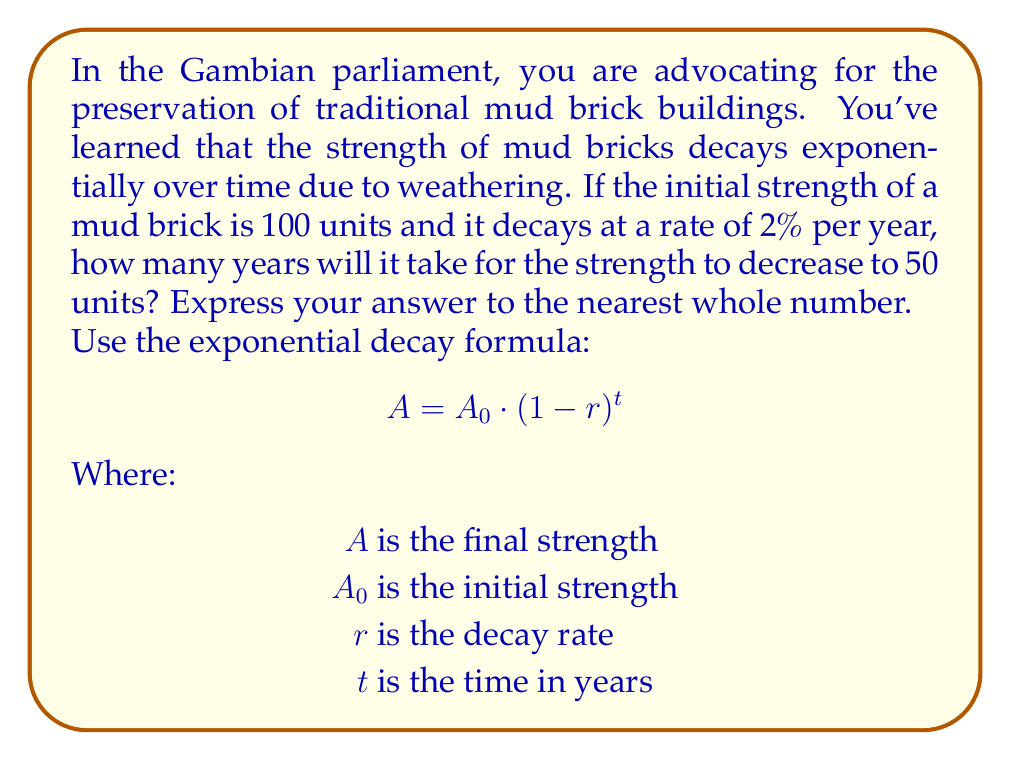What is the answer to this math problem? Let's approach this step-by-step:

1) We are given:
   $A_0 = 100$ (initial strength)
   $r = 0.02$ (2% decay rate)
   $A = 50$ (final strength)

2) We need to solve for $t$ in the equation:
   $$50 = 100 \cdot (1-0.02)^t$$

3) Simplify:
   $$50 = 100 \cdot (0.98)^t$$

4) Divide both sides by 100:
   $$0.5 = (0.98)^t$$

5) Take the natural log of both sides:
   $$\ln(0.5) = \ln((0.98)^t)$$

6) Use the logarithm property $\ln(a^b) = b\ln(a)$:
   $$\ln(0.5) = t \cdot \ln(0.98)$$

7) Solve for $t$:
   $$t = \frac{\ln(0.5)}{\ln(0.98)}$$

8) Use a calculator to evaluate:
   $$t \approx 34.3$$

9) Rounding to the nearest whole number:
   $t = 34$ years
Answer: 34 years 